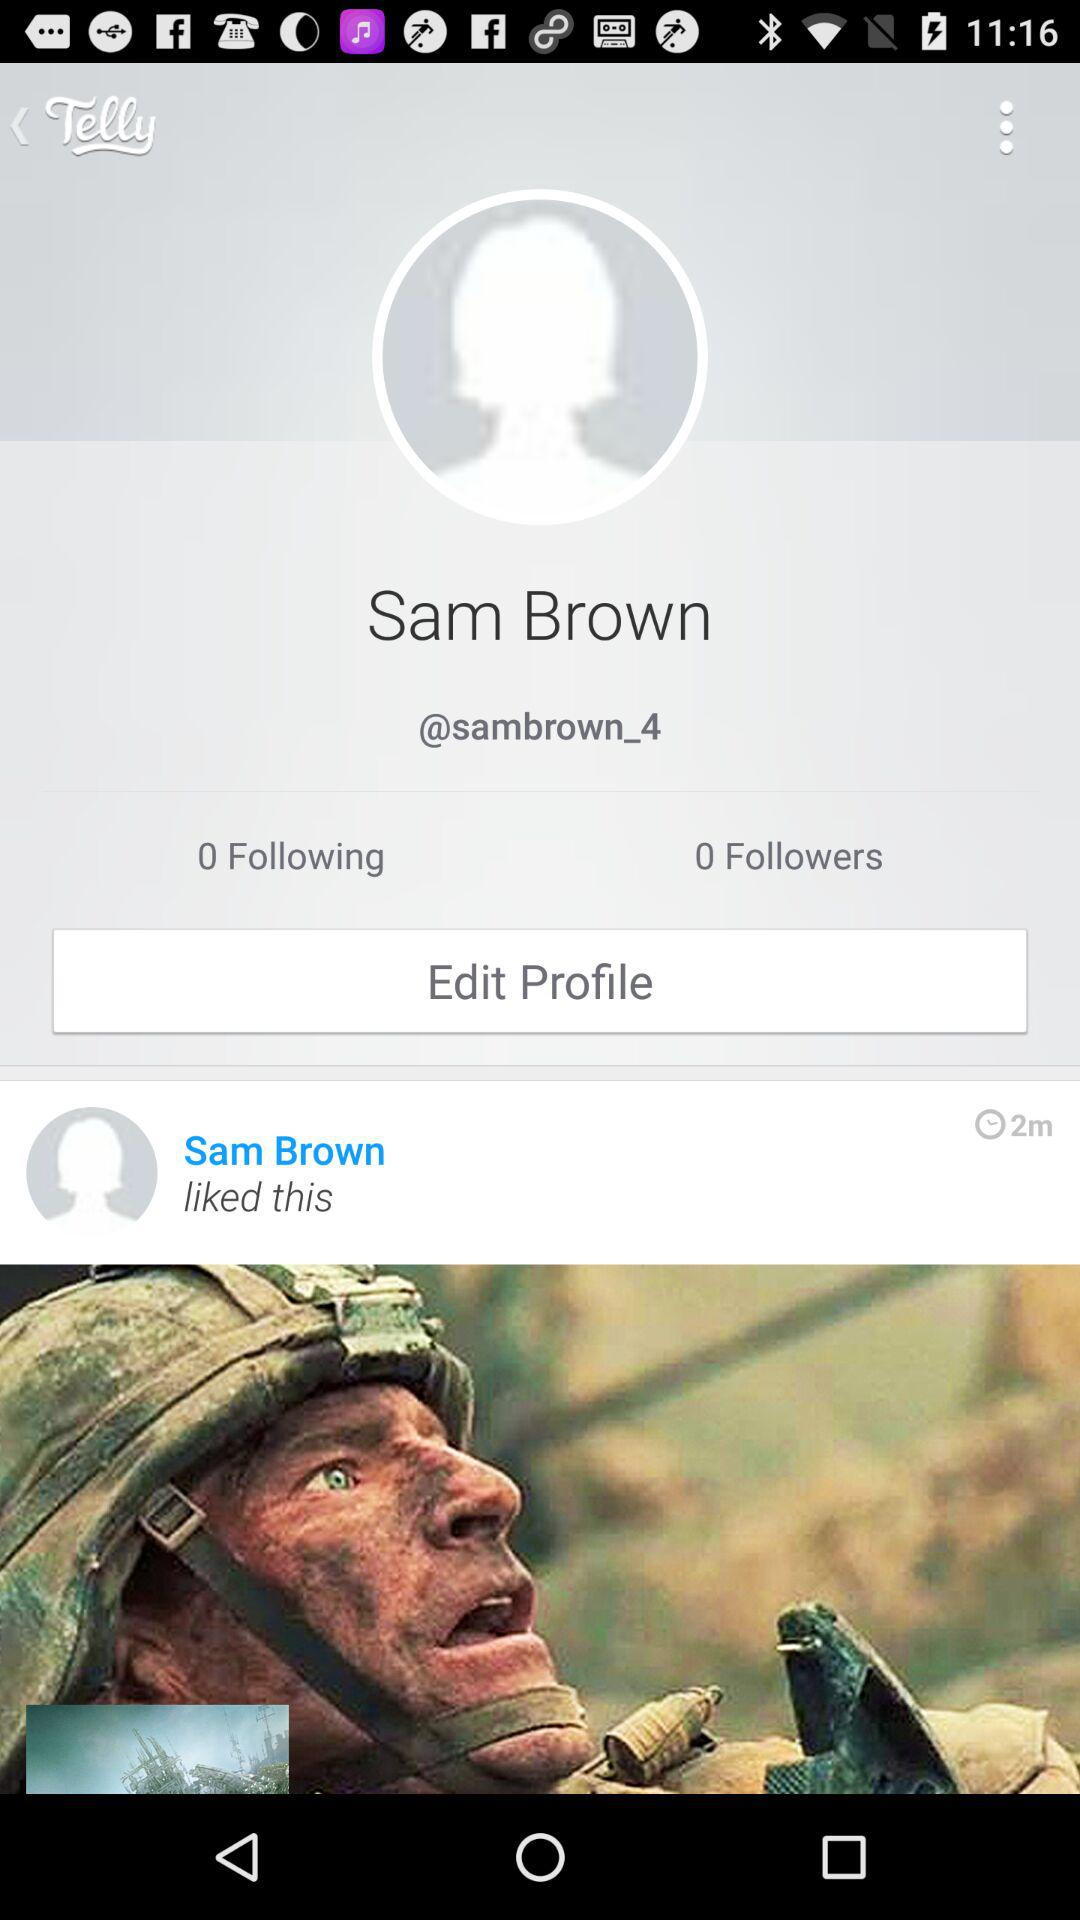What is the "Telly" ID of Sam Brown? The "Telly" ID is "@sambrown_4". 